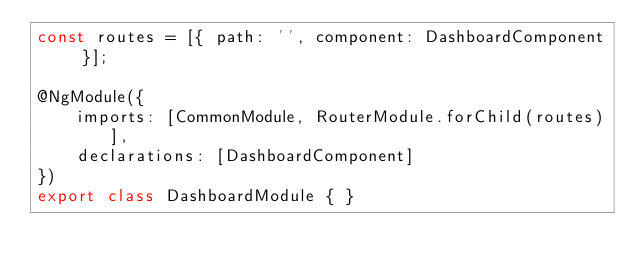<code> <loc_0><loc_0><loc_500><loc_500><_TypeScript_>const routes = [{ path: '', component: DashboardComponent }];

@NgModule({
    imports: [CommonModule, RouterModule.forChild(routes)],
    declarations: [DashboardComponent]
})
export class DashboardModule { }
</code> 